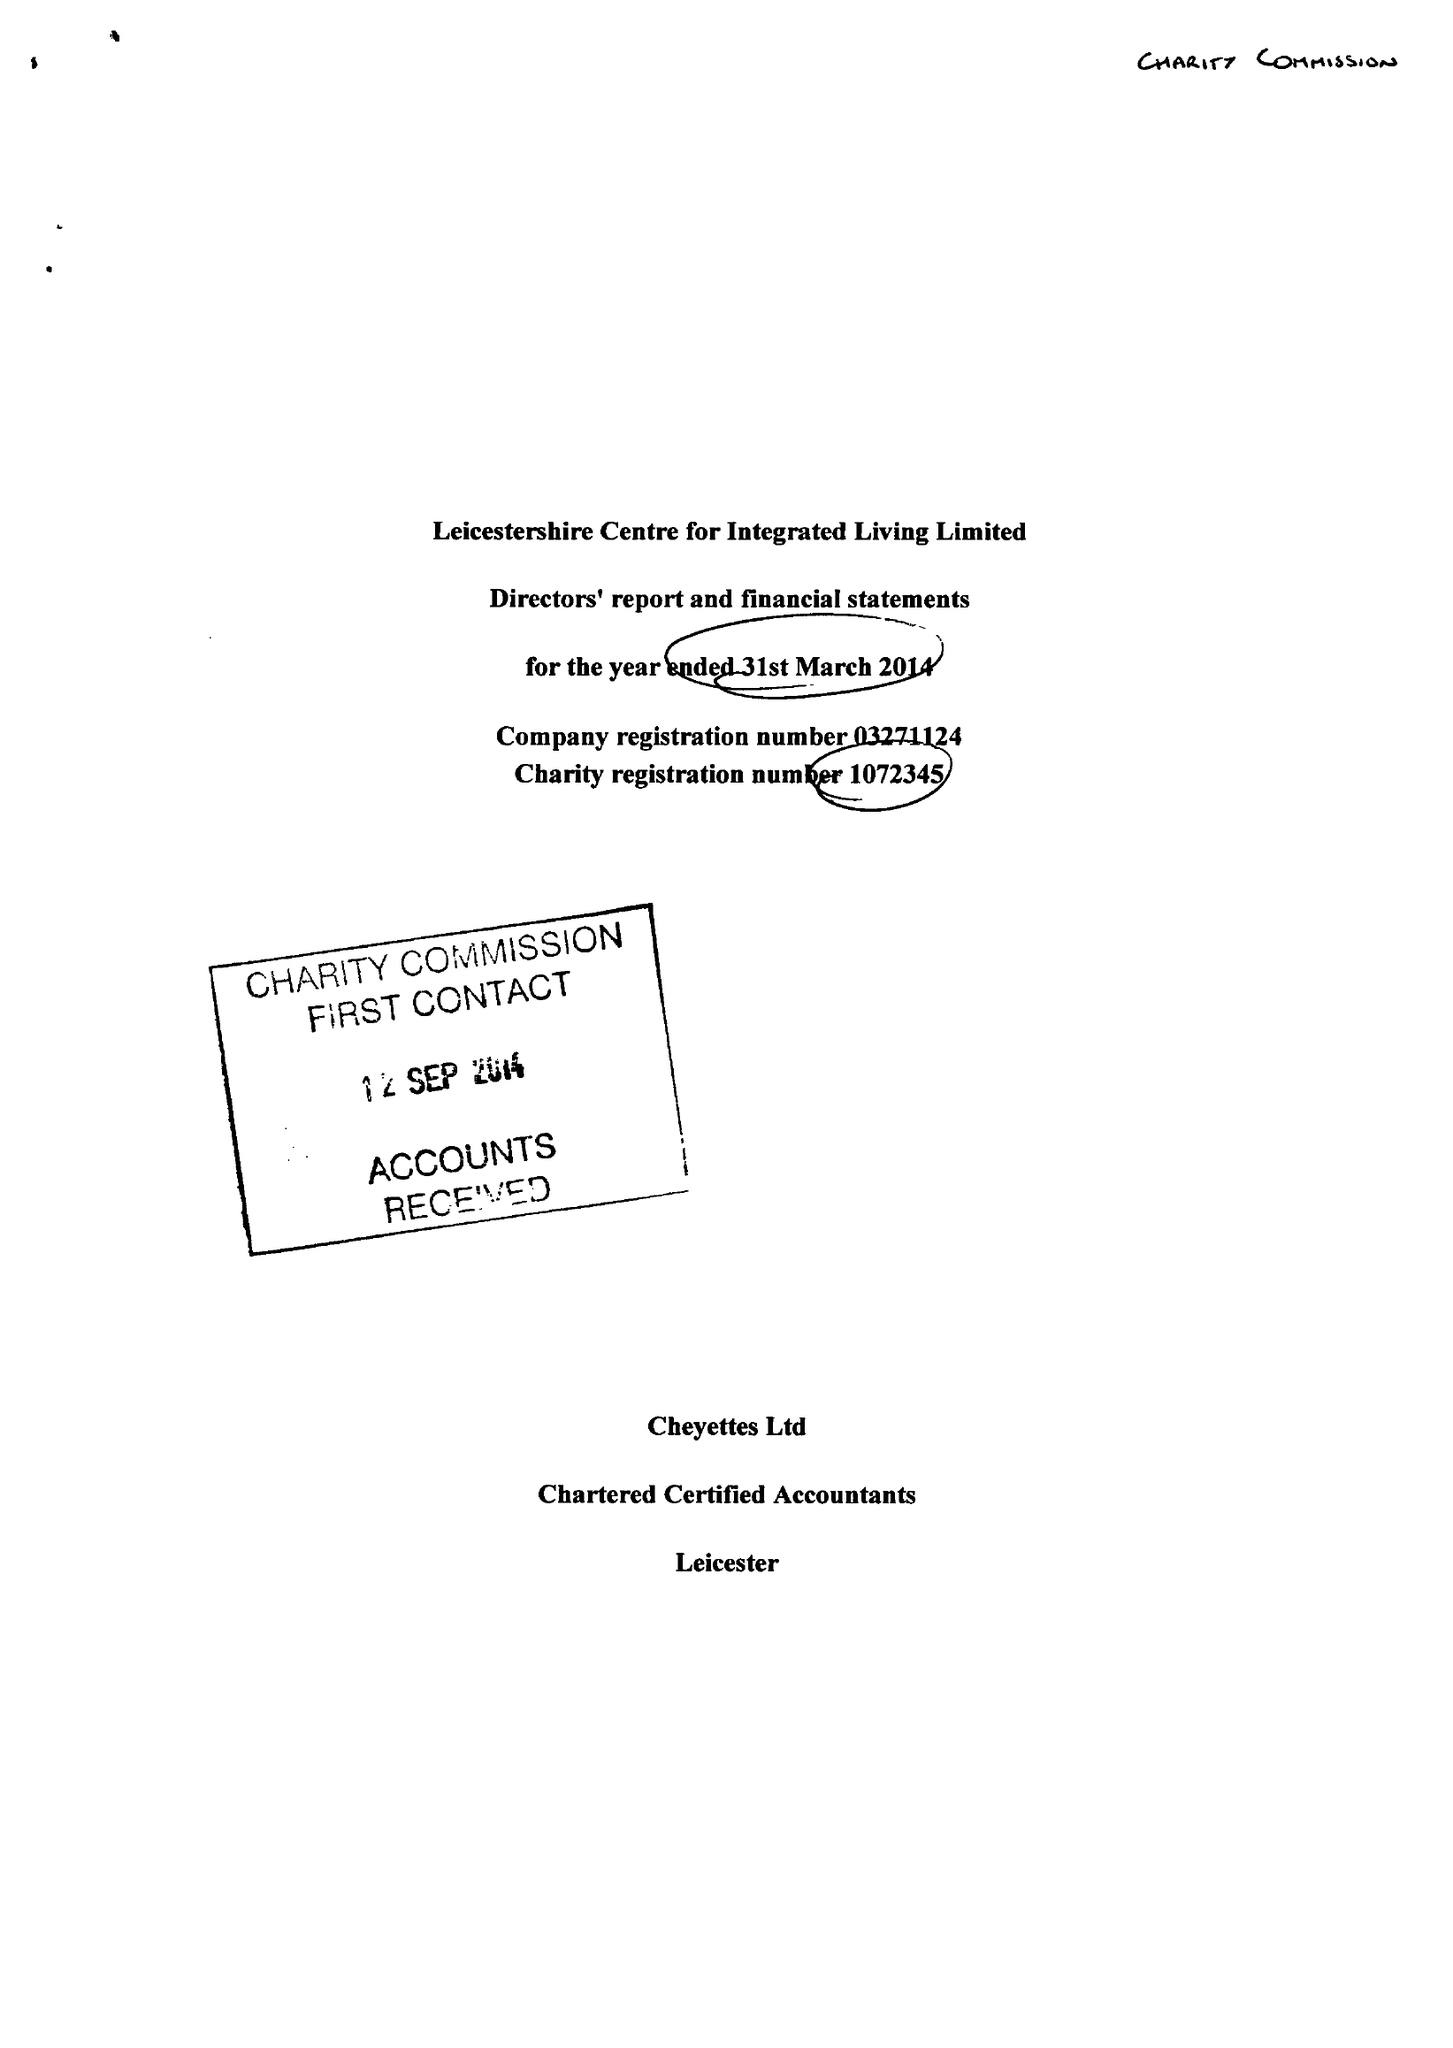What is the value for the address__postcode?
Answer the question using a single word or phrase. LE3 5PA 